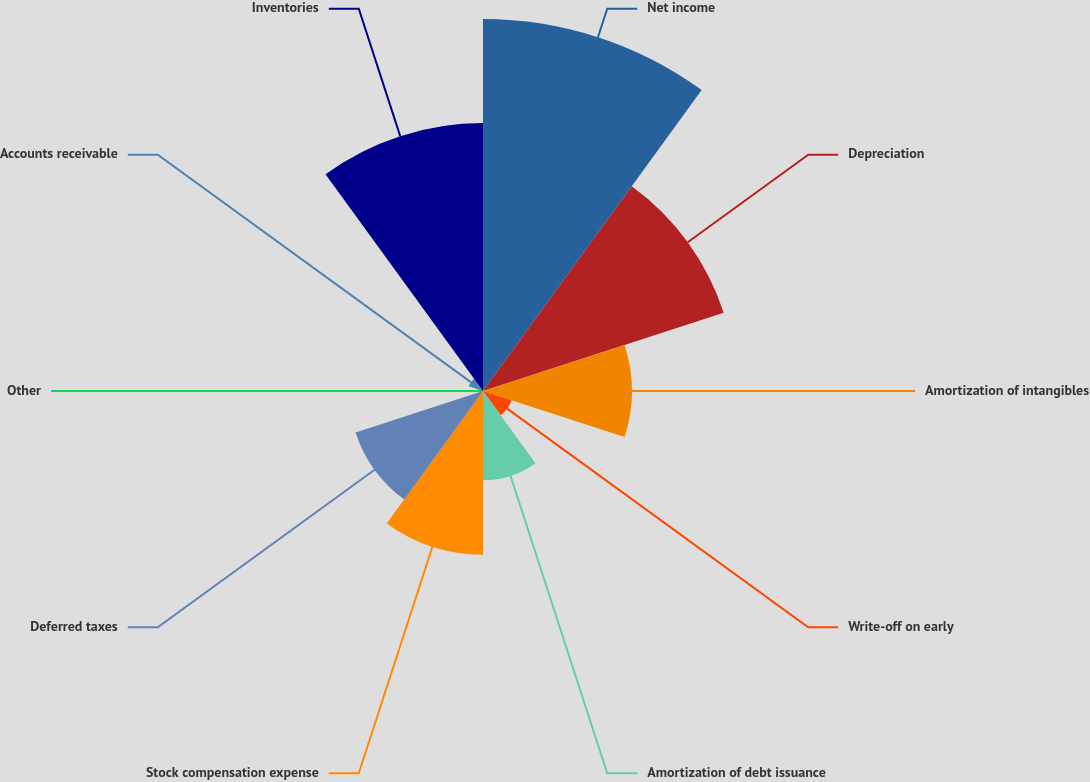Convert chart to OTSL. <chart><loc_0><loc_0><loc_500><loc_500><pie_chart><fcel>Net income<fcel>Depreciation<fcel>Amortization of intangibles<fcel>Write-off on early<fcel>Amortization of debt issuance<fcel>Stock compensation expense<fcel>Deferred taxes<fcel>Other<fcel>Accounts receivable<fcel>Inventories<nl><fcel>25.24%<fcel>17.17%<fcel>10.1%<fcel>2.03%<fcel>6.06%<fcel>11.11%<fcel>9.09%<fcel>0.01%<fcel>1.02%<fcel>18.18%<nl></chart> 